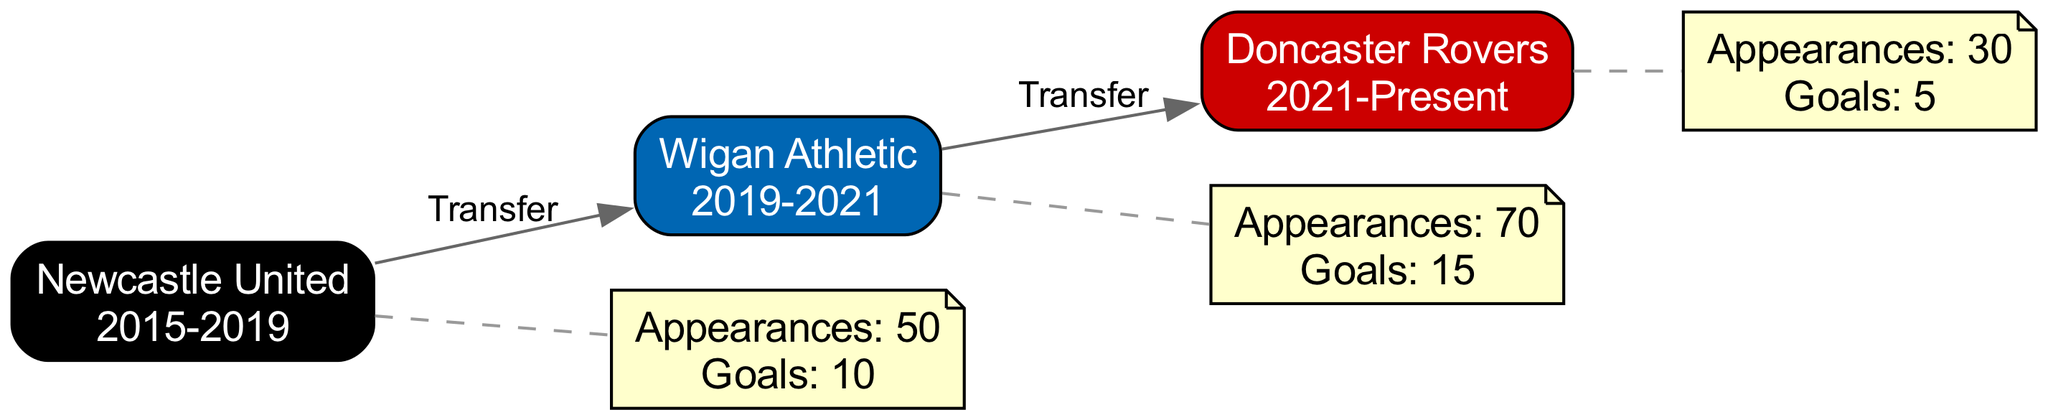What clubs has Matty Nicholson played for? The diagram lists three clubs: Newcastle United, Wigan Athletic, and Doncaster Rovers as the nodes.
Answer: Newcastle United, Wigan Athletic, Doncaster Rovers How many appearances did Matty Nicholson make at Wigan Athletic? The performance metrics for Wigan Athletic in the diagram show 70 appearances.
Answer: 70 What is the relationship between Newcastle United and Wigan Athletic? The diagram indicates there is a directed edge labeled "Transfer" connecting Newcastle United to Wigan Athletic.
Answer: Transfer How many goals did Matty Nicholson score for Doncaster Rovers? According to the performance metrics in the diagram, the goals scored for Doncaster Rovers are listed as 5.
Answer: 5 How many total clubs has Matty Nicholson transferred between? The diagram shows directed edges for transfers from Newcastle United to Wigan Athletic and then from Wigan Athletic to Doncaster Rovers, indicating two transfers.
Answer: 2 Which club did Matty Nicholson join after Wigan Athletic? The directed edge from Wigan Athletic to Doncaster Rovers shows that he joined Doncaster Rovers after Wigan Athletic.
Answer: Doncaster Rovers What was Matty Nicholson's total number of goals during his time at Newcastle United and Wigan Athletic combined? By adding the goals scored at Newcastle United (10) and Wigan Athletic (15), the total is calculated as 25 goals.
Answer: 25 Which club did Matty Nicholson play for the shortest period? Considering the periods listed, both Newcastle United and Wigan Athletic had longer periods compared to the ongoing term at Doncaster Rovers; hence, Wigan Athletic has the shortest time among completed terms.
Answer: Wigan Athletic What club's performance metrics show an appearance count higher than 50? The performance metrics reveal that Wigan Athletic with 70 appearances exceeds the 50 appearances mark.
Answer: Wigan Athletic 